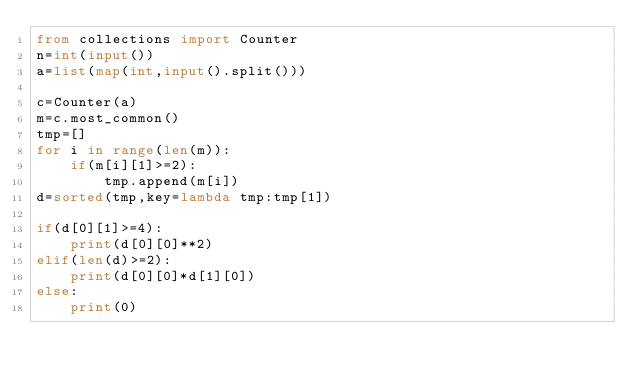<code> <loc_0><loc_0><loc_500><loc_500><_Python_>from collections import Counter
n=int(input())
a=list(map(int,input().split()))

c=Counter(a)
m=c.most_common()
tmp=[]
for i in range(len(m)):
    if(m[i][1]>=2):
        tmp.append(m[i])
d=sorted(tmp,key=lambda tmp:tmp[1])

if(d[0][1]>=4):
    print(d[0][0]**2)
elif(len(d)>=2):
    print(d[0][0]*d[1][0])
else:
    print(0)</code> 